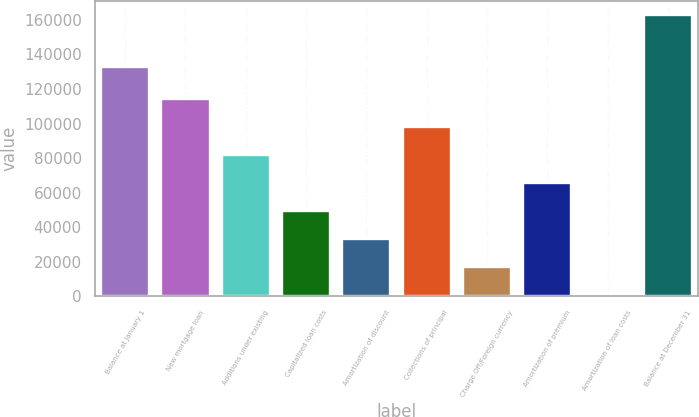Convert chart to OTSL. <chart><loc_0><loc_0><loc_500><loc_500><bar_chart><fcel>Balance at January 1<fcel>New mortgage loan<fcel>Additions under existing<fcel>Capitalized loan costs<fcel>Amortization of discount<fcel>Collections of principal<fcel>Charge Off/Foreign currency<fcel>Amortization of premium<fcel>Amortization of loan costs<fcel>Balance at December 31<nl><fcel>132675<fcel>114042<fcel>81623.5<fcel>49205.3<fcel>32996.2<fcel>97832.6<fcel>16787.1<fcel>65414.4<fcel>578<fcel>162669<nl></chart> 